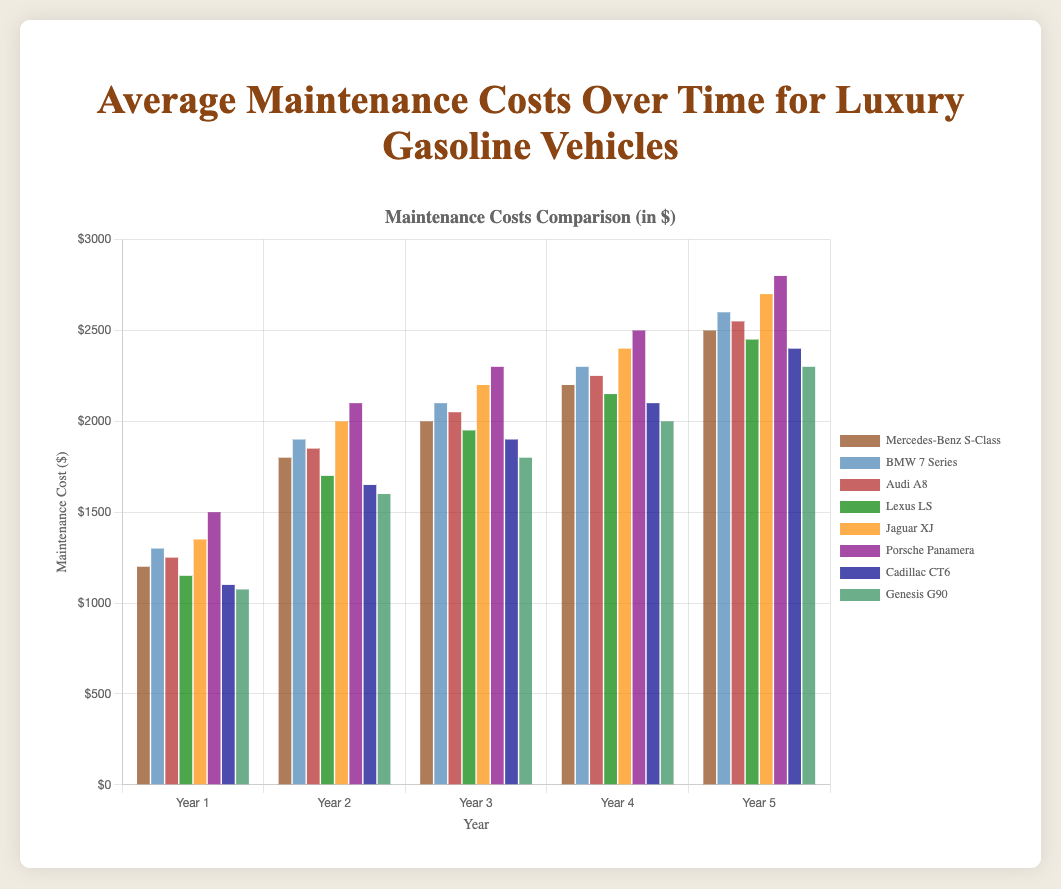Which luxury gasoline vehicle has the highest maintenance cost in Year 5? To determine which vehicle has the highest maintenance cost in Year 5, compare the heights of all bars labeled Year 5. The Porsche Panamera’s bar is the tallest at $2800.
Answer: Porsche Panamera What is the average maintenance cost for the BMW 7 Series over the 5 years? Add up the maintenance costs for the BMW 7 Series across all 5 years: 1300 + 1900 + 2100 + 2300 + 2600 = 10200, and divide by 5 to get the average. 10200 / 5 = 2040.
Answer: 2040 By how much does the maintenance cost for the Lexus LS increase from Year 1 to Year 5? Subtract the Year 1 cost from the Year 5 cost for the Lexus LS: 2450 - 1150 = 1300.
Answer: 1300 Which vehicles have a higher maintenance cost in Year 2 than the Mercedes-Benz S-Class in the same year? Mercedes-Benz S-Class maintenance cost in Year 2 is $1800. Compare this with other vehicles’ Year 2 costs. BMW 7 Series ($1900), Jaguar XJ ($2000), and Porsche Panamera ($2100) all have higher costs.
Answer: BMW 7 Series, Jaguar XJ, Porsche Panamera Is the increase in maintenance cost from Year 1 to Year 2 greater for the Audi A8 or the Cadillac CT6? Calculate the increase for both vehicles: Audi A8 (1850 - 1250 = 600), Cadillac CT6 (1650 - 1100 = 550). The increase is greater for the Audi A8.
Answer: Audi A8 Which vehicle shows the least total increase in maintenance costs over the 5 years? Calculate the total increase from Year 1 to Year 5 for each vehicle: 
Mercedes-Benz S-Class: 2500 - 1200 = 1300 
BMW 7 Series: 2600 - 1300 = 1300 
Audi A8: 2550 - 1250 = 1300 
Lexus LS: 2450 - 1150 = 1300 
Jaguar XJ: 2700 - 1350 = 1350 
Porsche Panamera: 2800 - 1500 = 1300 
Cadillac CT6: 2400 - 1100 = 1300 
Genesis G90: 2300 - 1075 = 1225 
Genesis G90 has the least increase of 1225.
Answer: Genesis G90 How does the maintenance cost of the Porsche Panamera in Year 3 compare to the Lexus LS in Year 4? Compare the maintenance costs: Porsche Panamera in Year 3 is $2300, and Lexus LS in Year 4 is $2150. Porsche Panamera’s cost is higher.
Answer: Higher What's the median maintenance cost in Year 4 across all listed vehicles? To find the median, list the Year 4 costs in ascending order:
1600, 1650, 1700, 1800, 1850, 2000, 2100, 2150, 2200, 2250, 2300, 2400, 2600, 2700. The median is the average of the 7th and 8th values, which are both $2150 and $2200, respectively:
(2150 + 2200) / 2 = 2175.
Answer: 2175 